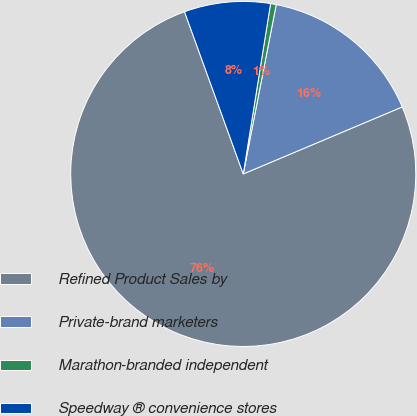<chart> <loc_0><loc_0><loc_500><loc_500><pie_chart><fcel>Refined Product Sales by<fcel>Private-brand marketers<fcel>Marathon-branded independent<fcel>Speedway ® convenience stores<nl><fcel>75.83%<fcel>15.59%<fcel>0.53%<fcel>8.06%<nl></chart> 